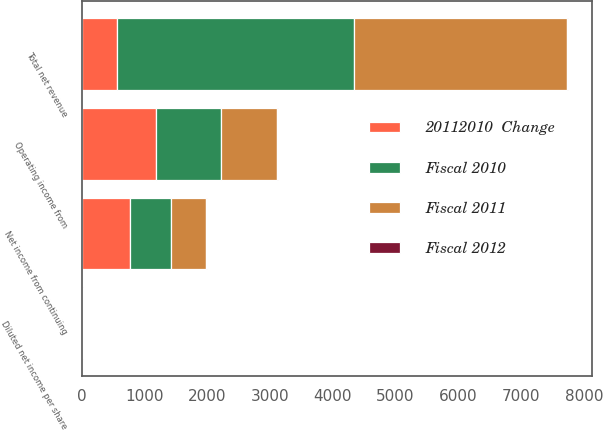Convert chart to OTSL. <chart><loc_0><loc_0><loc_500><loc_500><stacked_bar_chart><ecel><fcel>Total net revenue<fcel>Operating income from<fcel>Net income from continuing<fcel>Diluted net income per share<nl><fcel>20112010  Change<fcel>564<fcel>1177<fcel>767<fcel>2.52<nl><fcel>Fiscal 2010<fcel>3772<fcel>1037<fcel>652<fcel>2.06<nl><fcel>Fiscal 2011<fcel>3403<fcel>904<fcel>564<fcel>1.74<nl><fcel>Fiscal 2012<fcel>10<fcel>14<fcel>18<fcel>22<nl></chart> 